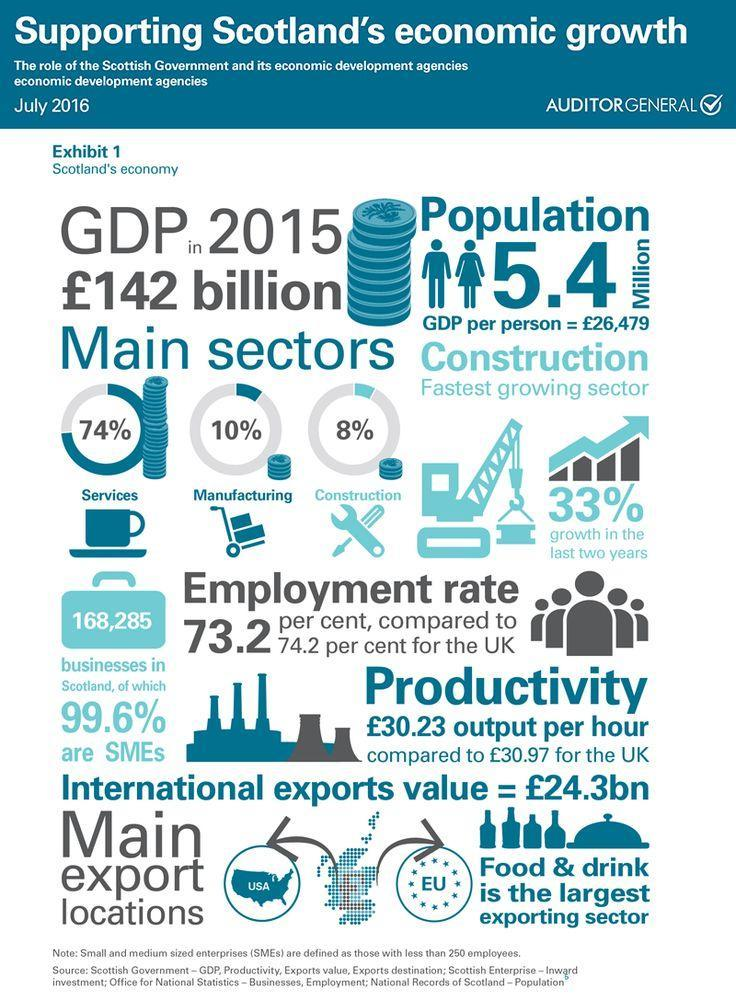How many export locations are main?
Answer the question with a short phrase. 2 By what percent did construction sector grow? 33% Which sector contributes to maximum GDP? Services How many businesses in Scotland are mentioned? 168,285 